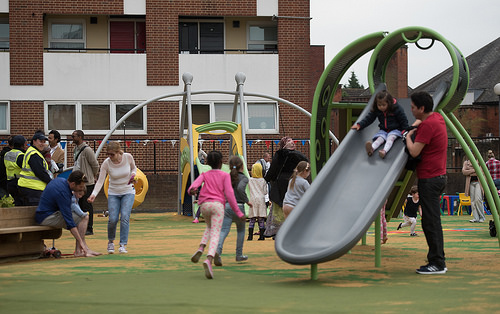<image>
Is the bench next to the man? Yes. The bench is positioned adjacent to the man, located nearby in the same general area. 